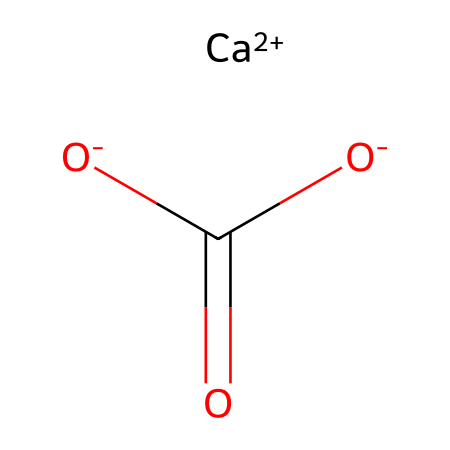How many calcium atoms are present in this structure? The SMILES representation includes the notation "[Ca+2]", indicating the presence of one calcium atom in its ionic form. Therefore, counting the "Ca" in the representation shows there is only one.
Answer: 1 What type of bond exists between calcium and the carboxylate group? Calcium is present as a cation "[Ca+2]", and it interacts with the carboxylate group which is composed of the two oxygen atoms "[O-]C(=O)[O-]". These interactions represent ion-ion interactions rather than covalent bonds.
Answer: ionic Which section of the structure indicates it acts as a base? The presence of the carboxylate moiety in the structure, indicated by the "O-COO-" arrangement, shows it can accept protons (H+) when acting as a base. This is characteristic of weak acids or bases.
Answer: carboxylate What is the formal charge on the oxygen atoms? The oxygen atoms in the carboxylate group are shown with "-" signs "[O-]", which means each of them has a formal charge of -1. This can be identified from the structure where both oxygen atoms indicate a negative charge.
Answer: -1 How many total negative charges does this molecule have? The molecule features two negatively charged oxygen atoms, each contributing a -1 charge when we account for the carboxylate. Therefore, the total negative charge is calculated by summing these contributions.
Answer: -2 Is this compound classified as an electrolyte? Yes, because it dissociates in solution into calcium ions (Ca2+) and carboxylate ions, allowing the conduction of electricity, a characteristic behavior of electrolytes.
Answer: yes 